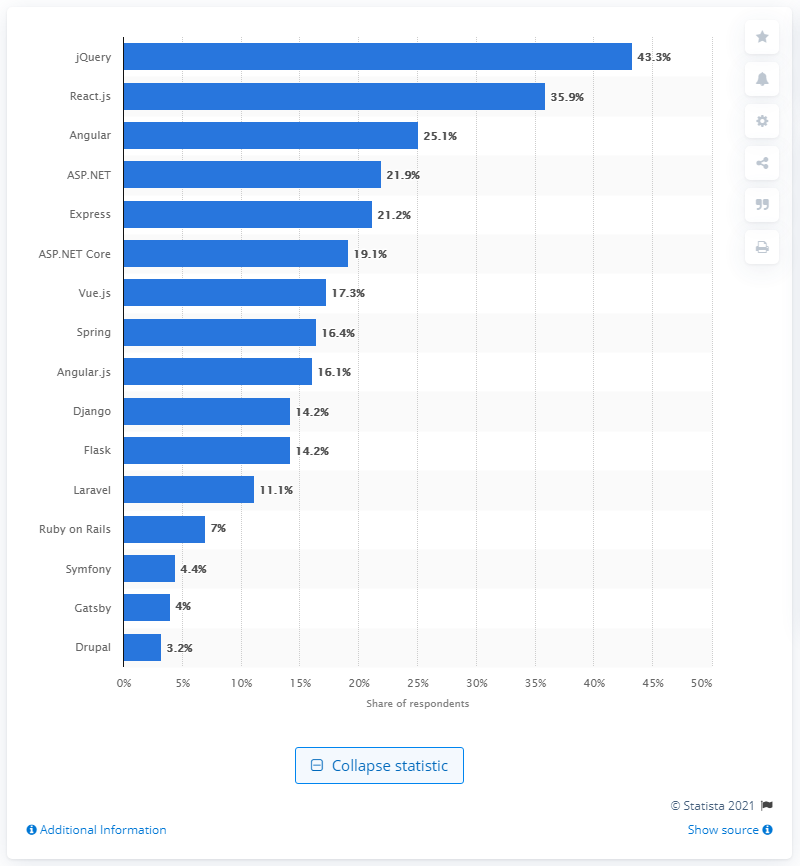Point out several critical features in this image. jQuery, a popular JavaScript library, has lost market share to React.js and Angular, two other frameworks for building web applications. As of early 2020, jQuery was the most widely utilized web framework among software developers worldwide. 